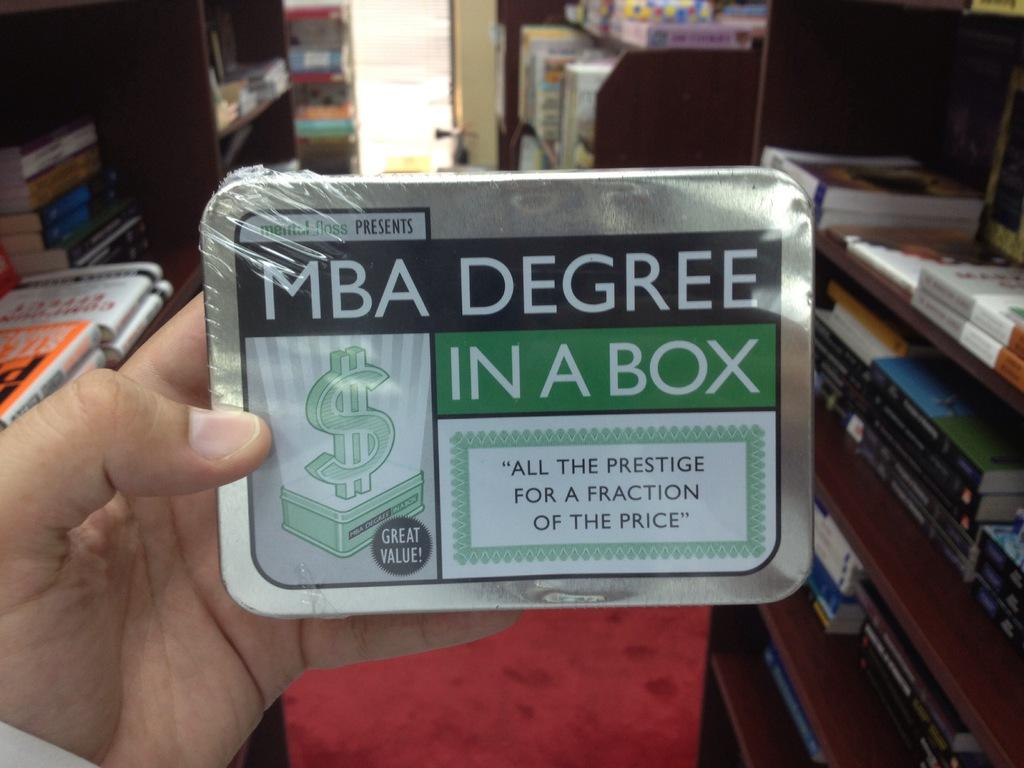Provide a one-sentence caption for the provided image. A shrink wrapped box contains a product named MBA Degree in a Box. 